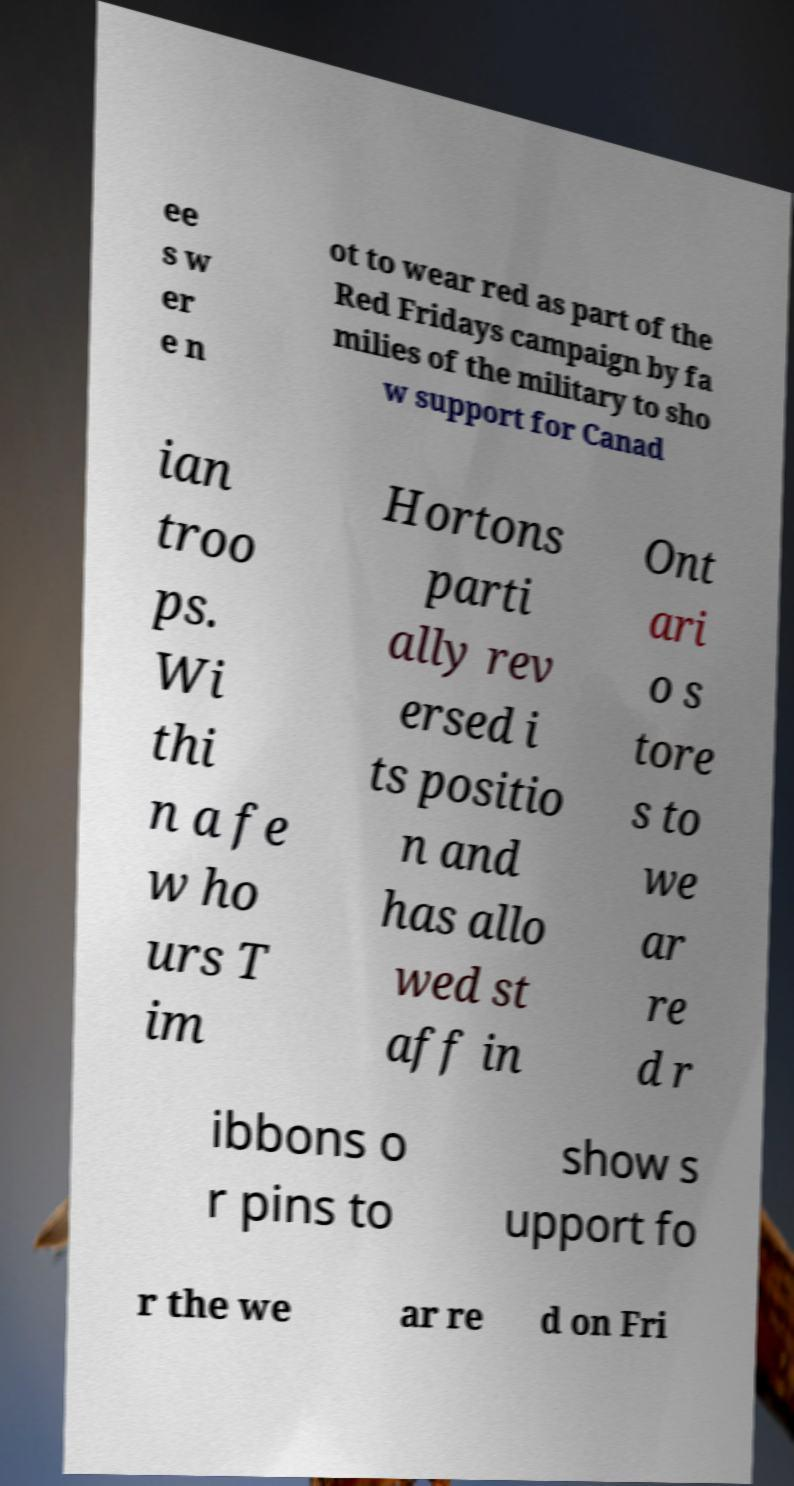Can you accurately transcribe the text from the provided image for me? ee s w er e n ot to wear red as part of the Red Fridays campaign by fa milies of the military to sho w support for Canad ian troo ps. Wi thi n a fe w ho urs T im Hortons parti ally rev ersed i ts positio n and has allo wed st aff in Ont ari o s tore s to we ar re d r ibbons o r pins to show s upport fo r the we ar re d on Fri 